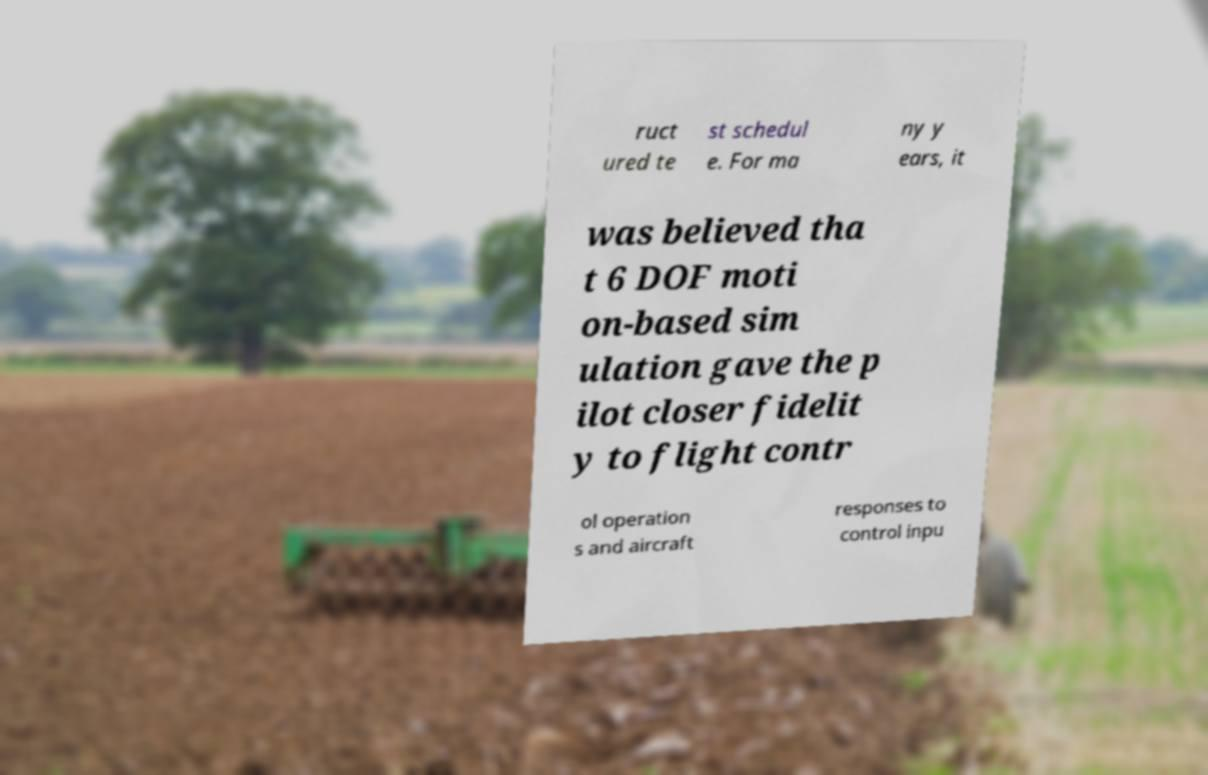Please identify and transcribe the text found in this image. ruct ured te st schedul e. For ma ny y ears, it was believed tha t 6 DOF moti on-based sim ulation gave the p ilot closer fidelit y to flight contr ol operation s and aircraft responses to control inpu 